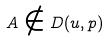<formula> <loc_0><loc_0><loc_500><loc_500>A \notin D ( u , p )</formula> 